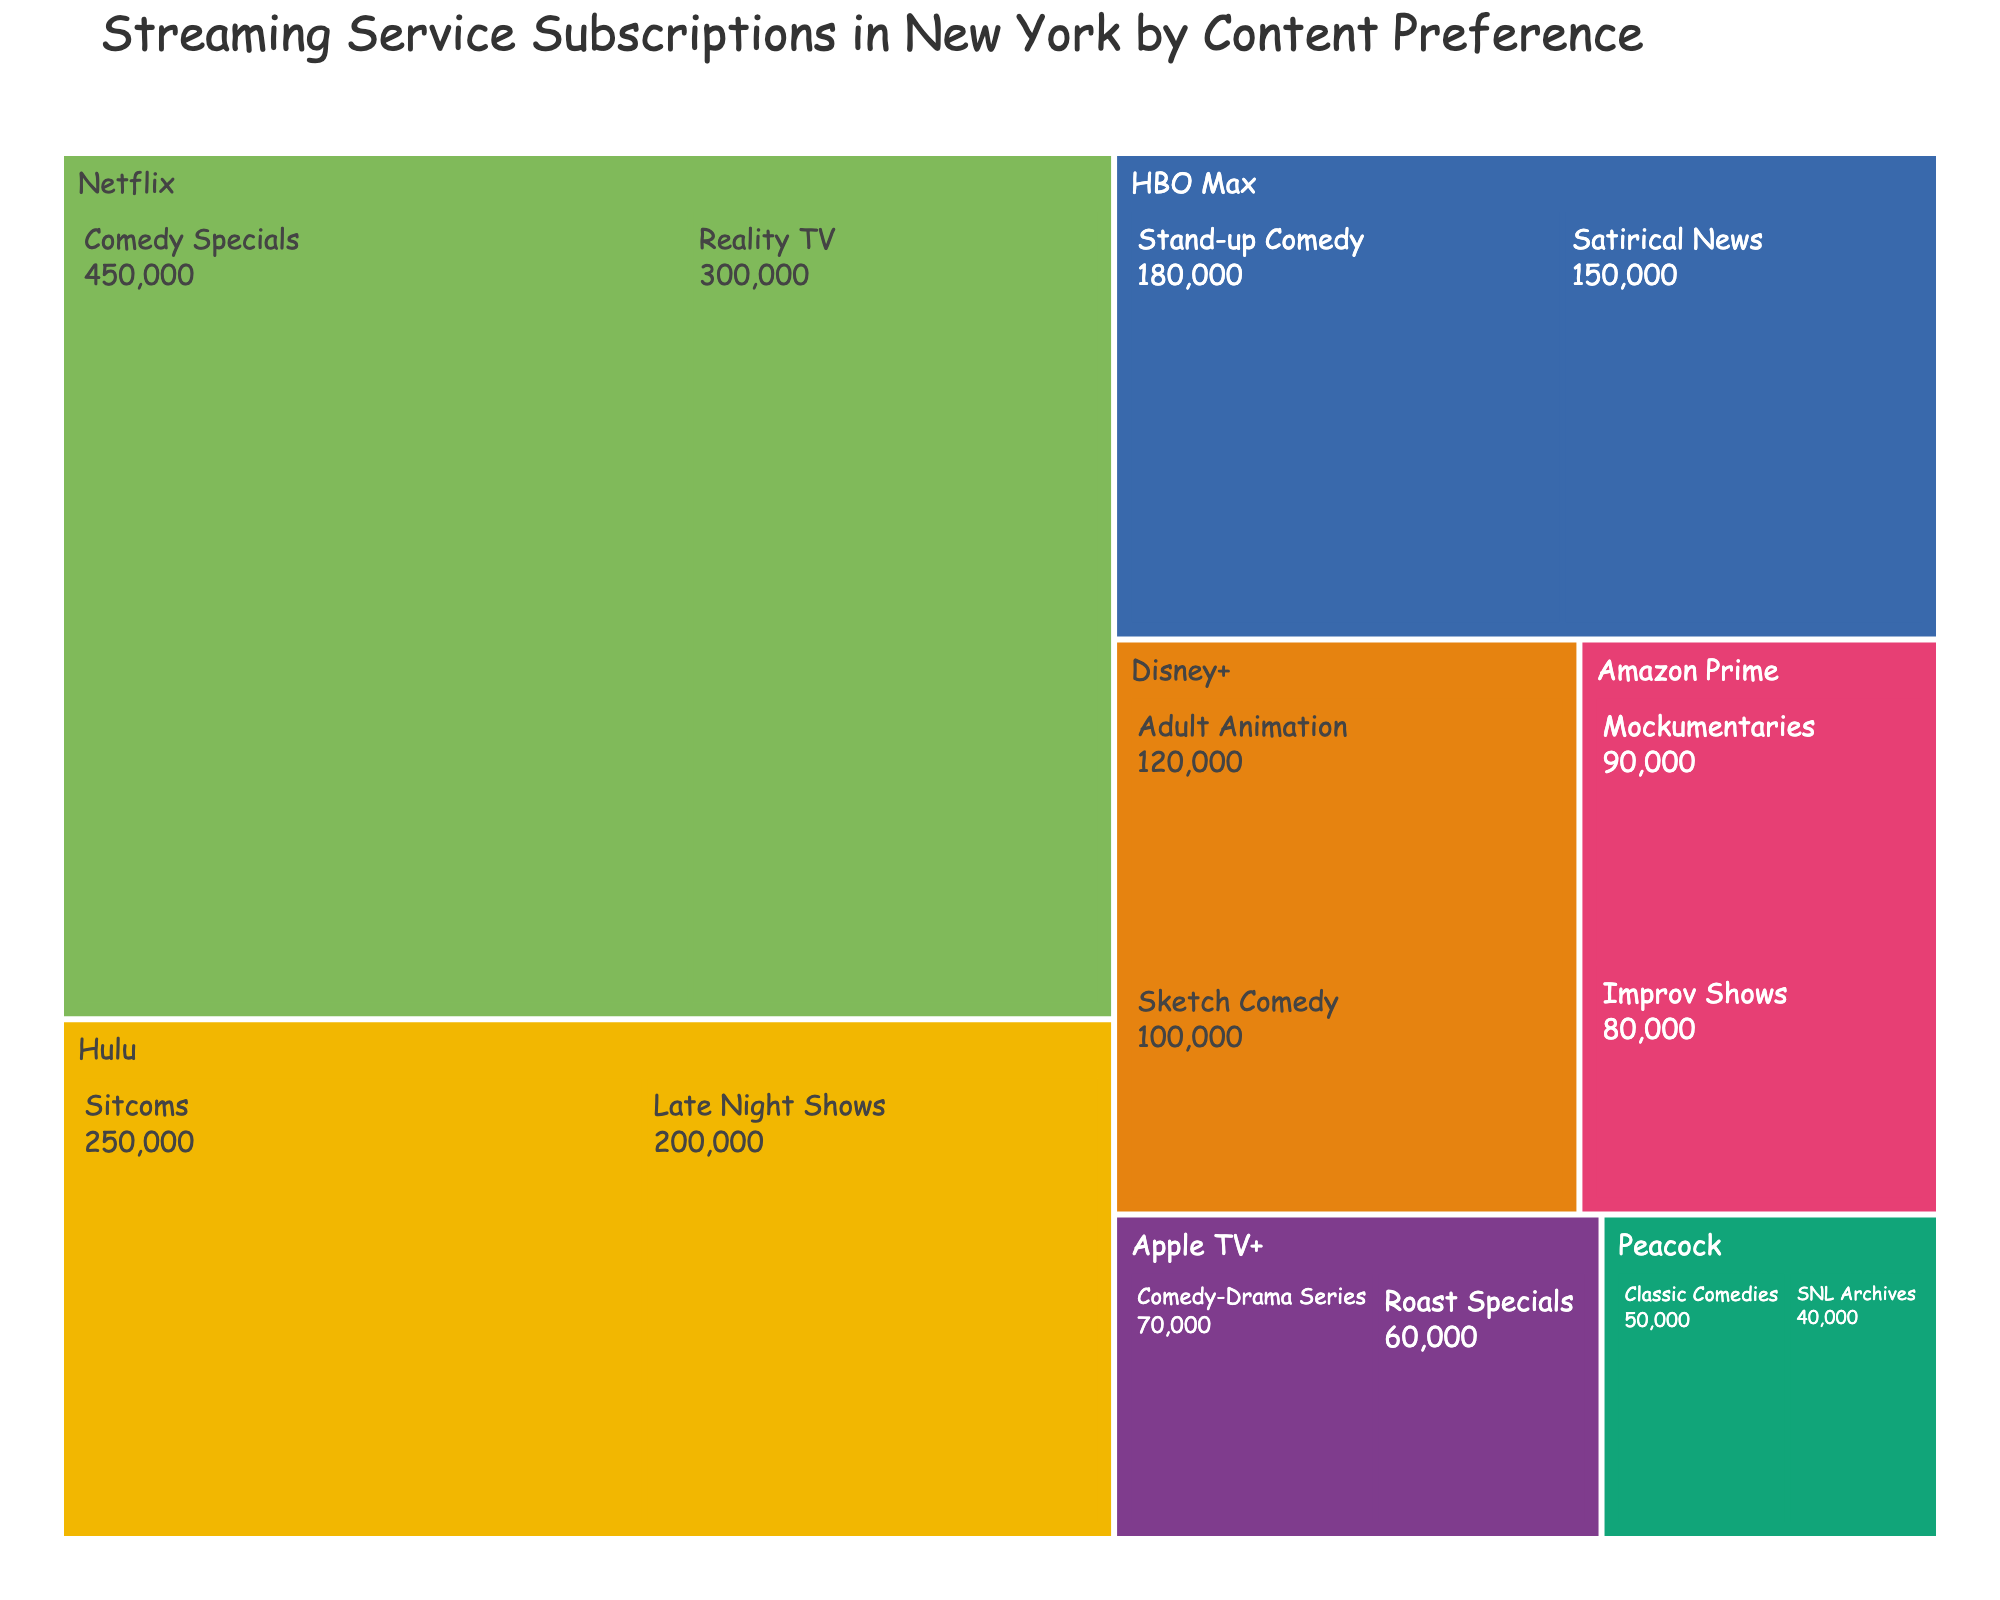What is the title of the treemap? The title is usually displayed at the top of the figure.
Answer: Streaming Service Subscriptions in New York by Content Preference Which streaming service has the highest number of subscribers for Comedy Specials? You can find this information by looking at the size of the boxes in the treemap, especially noting the service associated with Comedy Specials.
Answer: Netflix How many subscribers does Hulu have for Sitcoms? The number of subscribers is indicated inside the box associated with Hulu's Sitcoms.
Answer: 250,000 What is the total number of subscribers for Apple TV+? To find this, sum the subscribers for both content preferences under Apple TV+.
Answer: 130,000 Which content preference has more subscribers on HBO Max, Stand-up Comedy or Satirical News? Compare the size of the boxes within HBO Max for Stand-up Comedy and Satirical News.
Answer: Stand-up Comedy How many more subscribers does Netflix have for Reality TV compared to Apple TV+ for Comedy-Drama Series? Subtract the number of Apple TV+ Comedy-Drama series subscribers from the Netflix Reality TV subscribers.
Answer: 230,000 What is the service with the least number of subscribers for any given content preference, and what is that content preference? Look for the smallest box in the treemap and check the associated service and content preference labels.
Answer: Peacock, SNL Archives What is the average number of subscribers across all content preferences for Hulu? Add the number of subscribers for Hulu's content preferences and divide by the total number of preferences.
Answer: 225,000 Which service has more content preferences listed, Disney+ or Amazon Prime? Count the number of content preference boxes under Disney+ and Amazon Prime to see which is greater.
Answer: Disney+ Are there more Comedy Specials subscribers on Netflix or Stand-up Comedy subscribers on HBO Max? Compare the sizes of the boxes for Netflix Comedy Specials and HBO Max Stand-up Comedy.
Answer: Netflix 